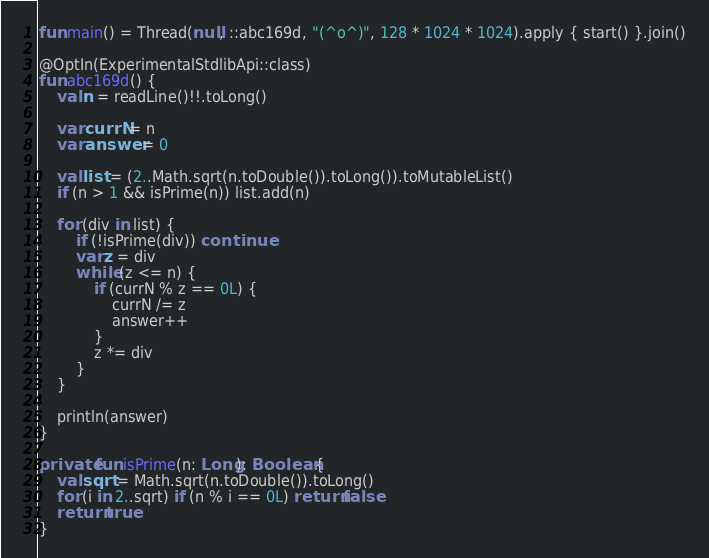Convert code to text. <code><loc_0><loc_0><loc_500><loc_500><_Kotlin_>fun main() = Thread(null, ::abc169d, "(^o^)", 128 * 1024 * 1024).apply { start() }.join()

@OptIn(ExperimentalStdlibApi::class)
fun abc169d() {
    val n = readLine()!!.toLong()

    var currN = n
    var answer = 0

    val list = (2..Math.sqrt(n.toDouble()).toLong()).toMutableList()
    if (n > 1 && isPrime(n)) list.add(n)

    for (div in list) {
        if (!isPrime(div)) continue
        var z = div
        while (z <= n) {
            if (currN % z == 0L) {
                currN /= z
                answer++
            }
            z *= div
        }
    }

    println(answer)
}

private fun isPrime(n: Long): Boolean {
    val sqrt = Math.sqrt(n.toDouble()).toLong()
    for (i in 2..sqrt) if (n % i == 0L) return false
    return true
}
</code> 